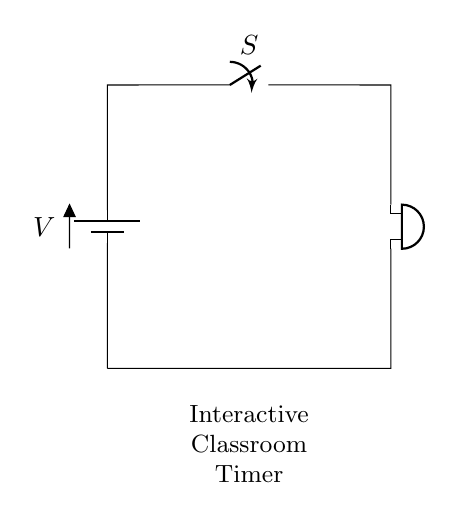What type of circuit is shown? The circuit is a series circuit, as all components are connected in a single path, which means the current flows through each component one after the other.
Answer: series circuit What component connects and controls the flow of current? The switch controls the flow of current in the circuit by either allowing or interrupting the current path when opened or closed.
Answer: switch What is the function of the buzzer in the circuit? The buzzer is used as an output component that produces sound when current flows through it, providing an audible alert for the timer.
Answer: buzzer How many components are in the circuit? There are three main components in the circuit: a battery, a switch, and a buzzer, each serving a distinct role in the operation of the circuit.
Answer: three What is the output of the circuit when the switch is closed? When the switch is closed, the circuit is complete, allowing current to flow from the battery to the buzzer, which then produces sound.
Answer: sound What happens if the switch is open? If the switch is open, it breaks the circuit, preventing current from flowing, which results in the buzzer not sounding, making it non-functioning.
Answer: no sound 